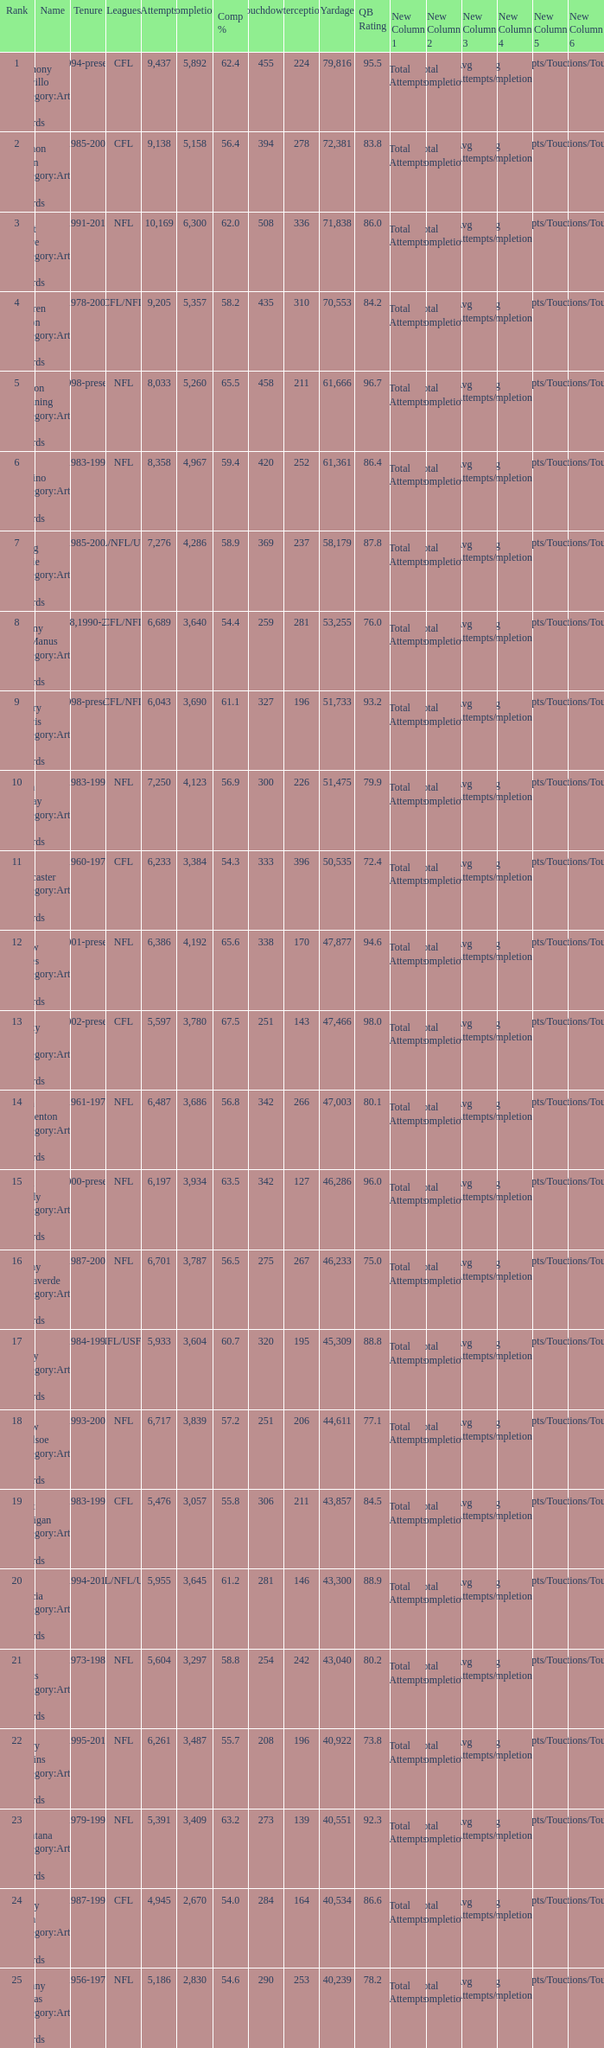What is the comp percentage when there are less than 44,611 in yardage, more than 254 touchdowns, and rank larger than 24? 54.6. 